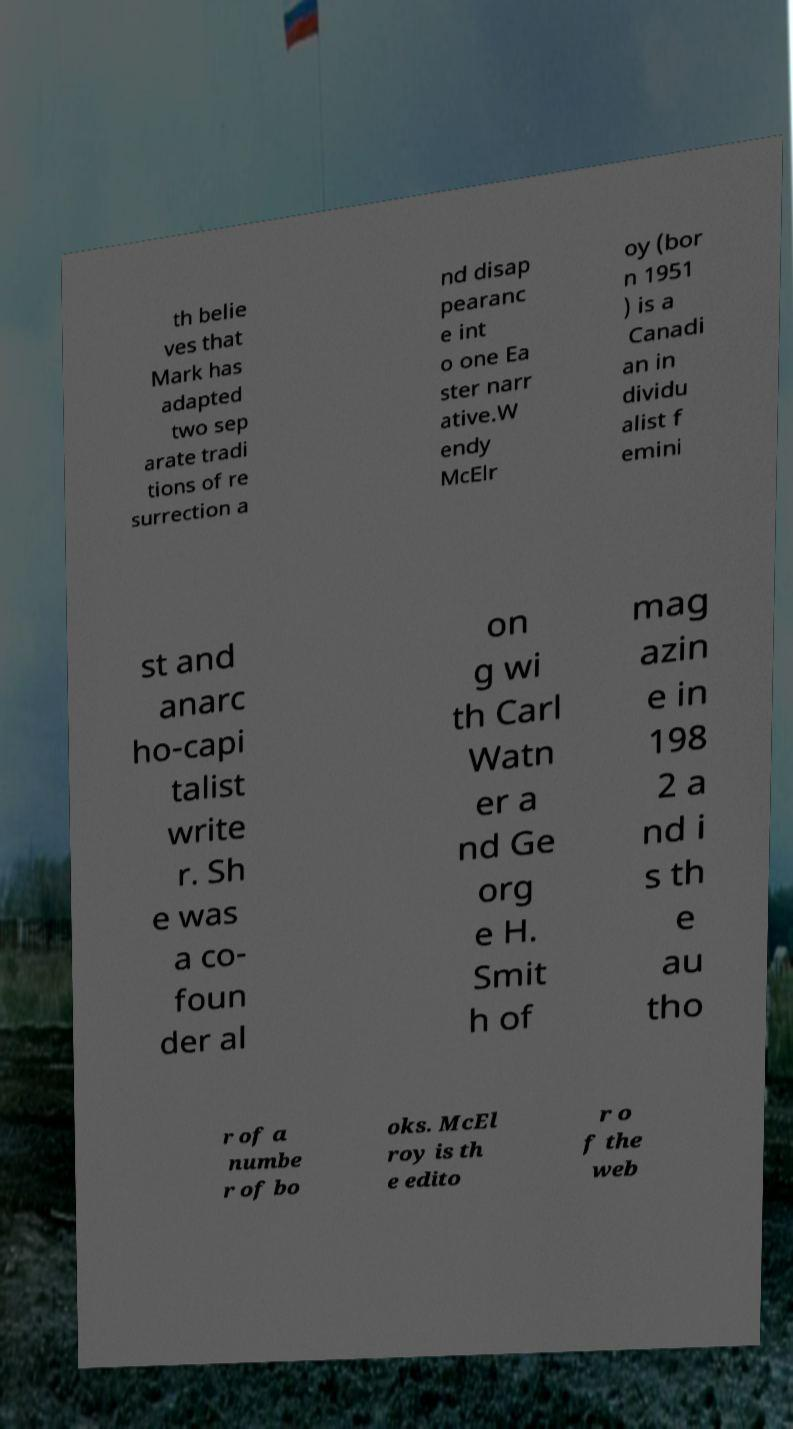Can you accurately transcribe the text from the provided image for me? th belie ves that Mark has adapted two sep arate tradi tions of re surrection a nd disap pearanc e int o one Ea ster narr ative.W endy McElr oy (bor n 1951 ) is a Canadi an in dividu alist f emini st and anarc ho-capi talist write r. Sh e was a co- foun der al on g wi th Carl Watn er a nd Ge org e H. Smit h of mag azin e in 198 2 a nd i s th e au tho r of a numbe r of bo oks. McEl roy is th e edito r o f the web 